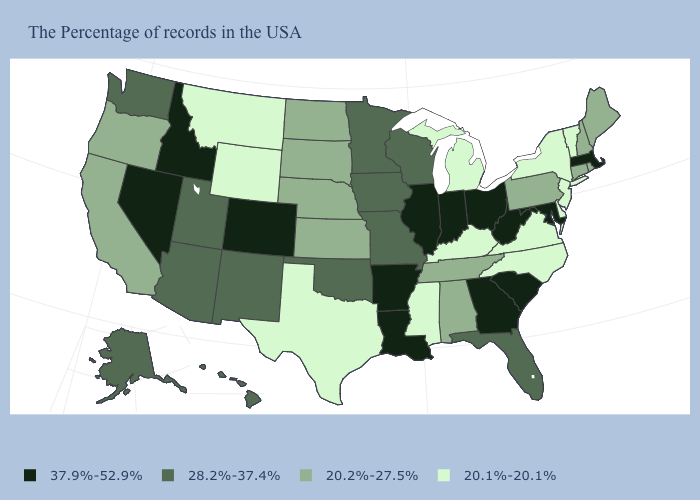What is the value of Michigan?
Be succinct. 20.1%-20.1%. Name the states that have a value in the range 20.2%-27.5%?
Quick response, please. Maine, Rhode Island, New Hampshire, Connecticut, Pennsylvania, Alabama, Tennessee, Kansas, Nebraska, South Dakota, North Dakota, California, Oregon. Name the states that have a value in the range 20.1%-20.1%?
Keep it brief. Vermont, New York, New Jersey, Delaware, Virginia, North Carolina, Michigan, Kentucky, Mississippi, Texas, Wyoming, Montana. Does the map have missing data?
Quick response, please. No. What is the value of Wyoming?
Give a very brief answer. 20.1%-20.1%. Does Colorado have the highest value in the West?
Be succinct. Yes. Name the states that have a value in the range 20.2%-27.5%?
Answer briefly. Maine, Rhode Island, New Hampshire, Connecticut, Pennsylvania, Alabama, Tennessee, Kansas, Nebraska, South Dakota, North Dakota, California, Oregon. Among the states that border New Hampshire , which have the highest value?
Be succinct. Massachusetts. What is the highest value in states that border West Virginia?
Short answer required. 37.9%-52.9%. What is the highest value in states that border Delaware?
Short answer required. 37.9%-52.9%. What is the value of Utah?
Quick response, please. 28.2%-37.4%. Which states have the highest value in the USA?
Concise answer only. Massachusetts, Maryland, South Carolina, West Virginia, Ohio, Georgia, Indiana, Illinois, Louisiana, Arkansas, Colorado, Idaho, Nevada. What is the highest value in the USA?
Answer briefly. 37.9%-52.9%. What is the value of Wyoming?
Short answer required. 20.1%-20.1%. How many symbols are there in the legend?
Short answer required. 4. 